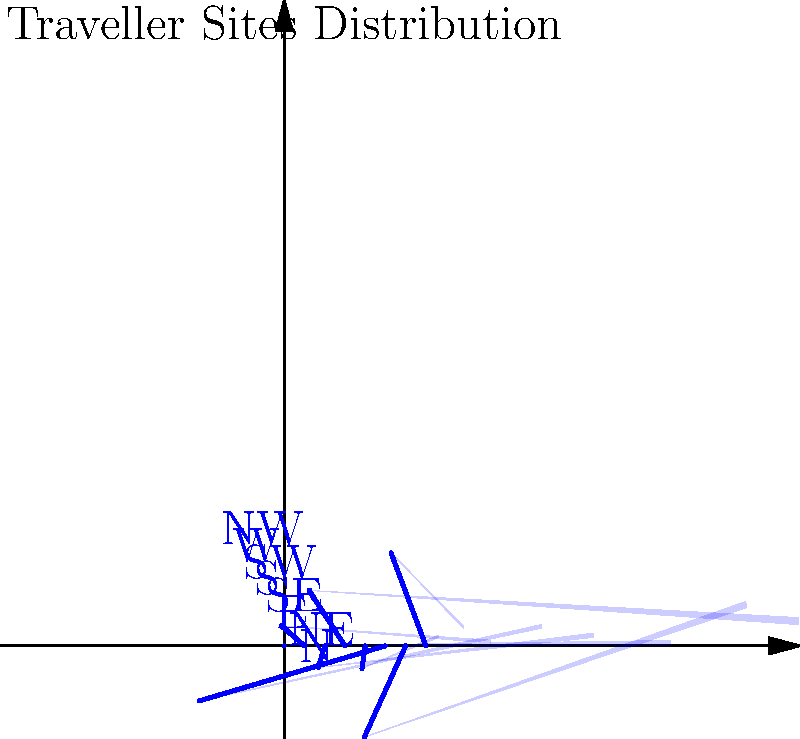The polar histogram above shows the distribution of Traveller sites around a major city. In which direction from the city center are Traveller sites most prevalent? To determine the direction with the most Traveller sites, we need to analyze the polar histogram:

1. The histogram is divided into 8 directions: N, NE, E, SE, S, SW, W, and NW.
2. Each direction is represented by a "slice" of the histogram.
3. The length of each slice indicates the number of Traveller sites in that direction.
4. We need to identify the longest slice, which represents the highest number of sites.

Examining the histogram:
- North (N): moderate length
- Northeast (NE): short length
- East (E): medium length
- Southeast (SE): longest slice
- South (S): shortest length
- Southwest (SW): medium length
- West (W): second longest slice
- Northwest (NW): short length

The longest slice corresponds to the Southeast (SE) direction, indicating that this is where Traveller sites are most prevalent around the city.
Answer: Southeast (SE) 